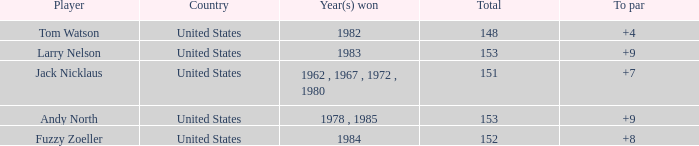What is the Total of the Player with a To par of 4? 1.0. Could you parse the entire table as a dict? {'header': ['Player', 'Country', 'Year(s) won', 'Total', 'To par'], 'rows': [['Tom Watson', 'United States', '1982', '148', '+4'], ['Larry Nelson', 'United States', '1983', '153', '+9'], ['Jack Nicklaus', 'United States', '1962 , 1967 , 1972 , 1980', '151', '+7'], ['Andy North', 'United States', '1978 , 1985', '153', '+9'], ['Fuzzy Zoeller', 'United States', '1984', '152', '+8']]} 